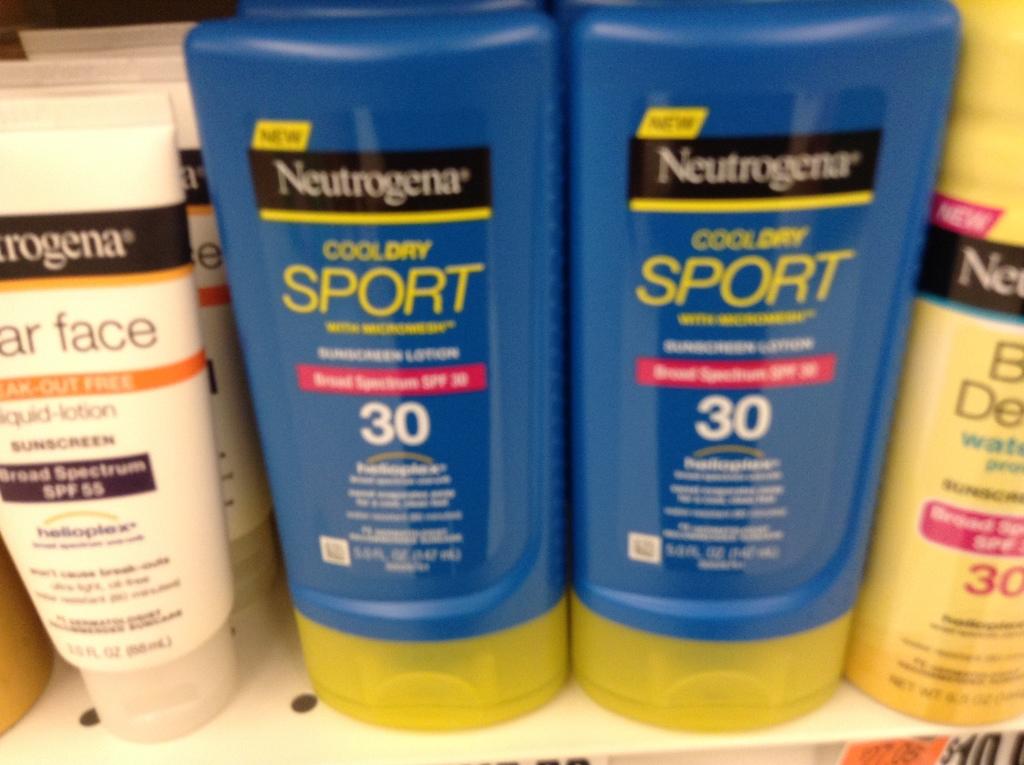How many spf is this?
Offer a terse response. 30. 